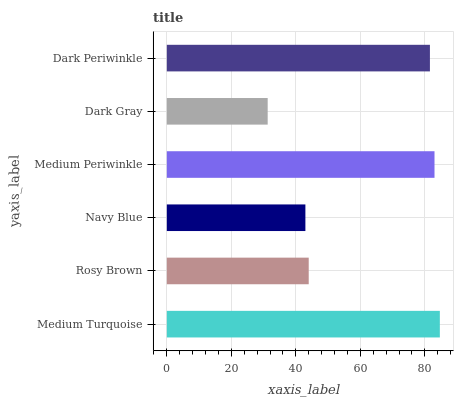Is Dark Gray the minimum?
Answer yes or no. Yes. Is Medium Turquoise the maximum?
Answer yes or no. Yes. Is Rosy Brown the minimum?
Answer yes or no. No. Is Rosy Brown the maximum?
Answer yes or no. No. Is Medium Turquoise greater than Rosy Brown?
Answer yes or no. Yes. Is Rosy Brown less than Medium Turquoise?
Answer yes or no. Yes. Is Rosy Brown greater than Medium Turquoise?
Answer yes or no. No. Is Medium Turquoise less than Rosy Brown?
Answer yes or no. No. Is Dark Periwinkle the high median?
Answer yes or no. Yes. Is Rosy Brown the low median?
Answer yes or no. Yes. Is Dark Gray the high median?
Answer yes or no. No. Is Dark Gray the low median?
Answer yes or no. No. 